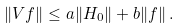Convert formula to latex. <formula><loc_0><loc_0><loc_500><loc_500>\| V f \| \leq a \| H _ { 0 } \| + b \| f \| \, .</formula> 